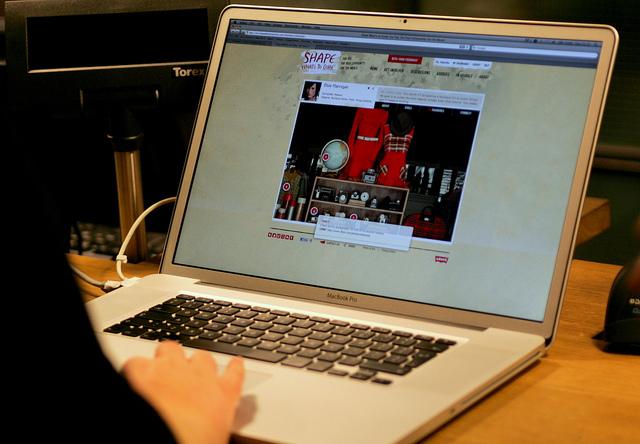Are these laptops used for fun or work?
Answer briefly. Fun. What model is that laptop?
Give a very brief answer. Macbook pro. What type of computer is this person using?
Keep it brief. Laptop. What color is the computer?
Give a very brief answer. Silver. What color is the laptop?
Quick response, please. Gray. How many people are shown on the computer?
Be succinct. 2. Is this an IBM laptop?
Quick response, please. No. Is the computer turned on?
Short answer required. Yes. Is this computer compatible with a Dell?
Concise answer only. Yes. What program is open on the screen?
Answer briefly. Internet browser. How many keys are on the laptop keyboard?
Give a very brief answer. 80. 